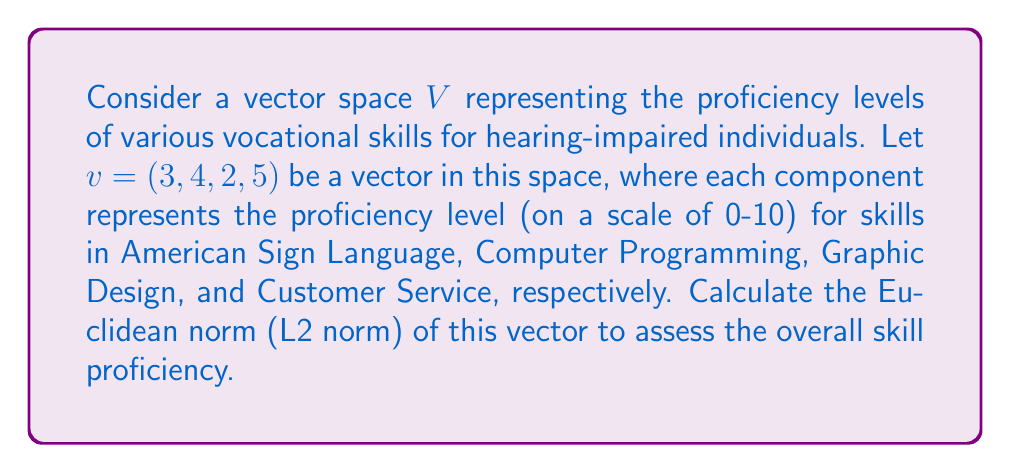Can you solve this math problem? To calculate the Euclidean norm (L2 norm) of the vector $v = (3, 4, 2, 5)$, we follow these steps:

1) The Euclidean norm is defined as:

   $$\|v\|_2 = \sqrt{\sum_{i=1}^n |v_i|^2}$$

   where $n$ is the dimension of the vector and $v_i$ are the components of the vector.

2) In this case, we have:
   
   $$\|v\|_2 = \sqrt{|3|^2 + |4|^2 + |2|^2 + |5|^2}$$

3) Simplify the expression under the square root:

   $$\|v\|_2 = \sqrt{9 + 16 + 4 + 25}$$

4) Add the numbers under the square root:

   $$\|v\|_2 = \sqrt{54}$$

5) Simplify the square root:

   $$\|v\|_2 = 3\sqrt{6}$$

This result represents the overall skill proficiency level, taking into account all four skills simultaneously. A higher norm indicates a higher overall proficiency across the skills.
Answer: The Euclidean norm of the vector $v$ is $3\sqrt{6}$. 